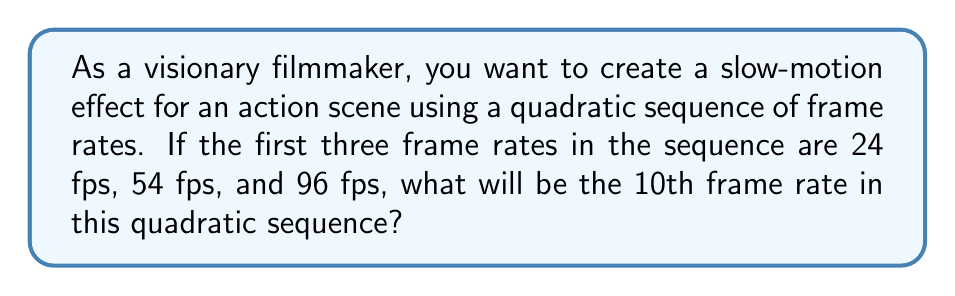Teach me how to tackle this problem. Let's approach this step-by-step:

1) A quadratic sequence has the general form $a_n = an^2 + bn + c$, where $n$ is the position in the sequence.

2) We have the first three terms:
   $a_1 = 24$
   $a_2 = 54$
   $a_3 = 96$

3) Let's substitute these into our general form:
   $24 = a(1)^2 + b(1) + c$
   $54 = a(2)^2 + b(2) + c$
   $96 = a(3)^2 + b(3) + c$

4) Simplify:
   $24 = a + b + c$
   $54 = 4a + 2b + c$
   $96 = 9a + 3b + c$

5) Subtract the first equation from the second:
   $30 = 3a + b$

6) Subtract the first equation from the third:
   $72 = 8a + 2b$

7) Multiply the equation from step 5 by 2:
   $60 = 6a + 2b$

8) Subtract this from the equation in step 6:
   $12 = 2a$
   $a = 6$

9) Substitute this back into the equation from step 5:
   $30 = 3(6) + b$
   $30 = 18 + b$
   $b = 12$

10) Now use the first equation to find $c$:
    $24 = 6 + 12 + c$
    $c = 6$

11) So our quadratic sequence is:
    $a_n = 6n^2 + 12n + 6$

12) To find the 10th term, substitute $n = 10$:
    $a_{10} = 6(10)^2 + 12(10) + 6$
    $= 600 + 120 + 6$
    $= 726$

Therefore, the 10th frame rate in the sequence will be 726 fps.
Answer: 726 fps 